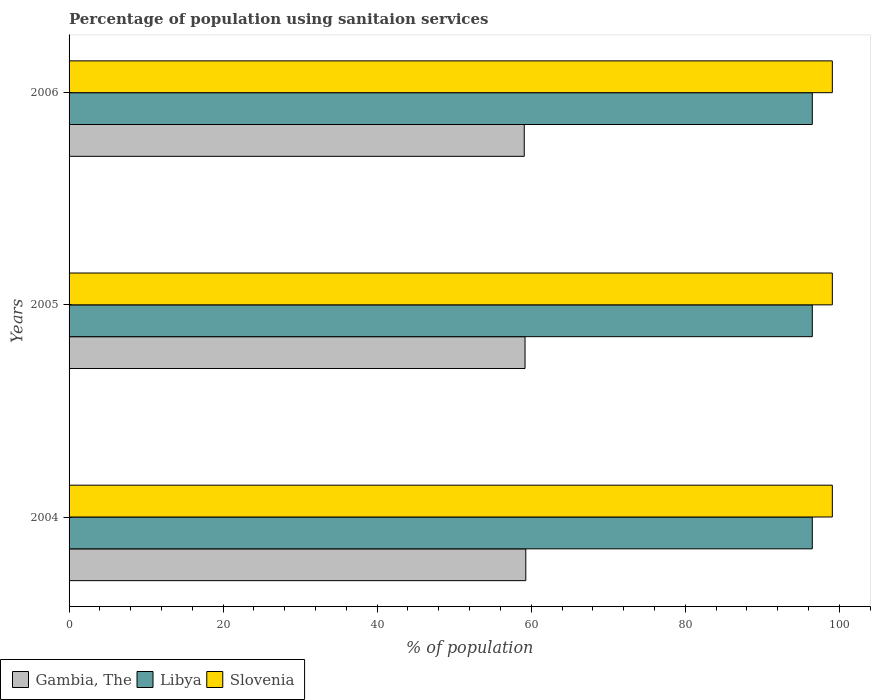How many different coloured bars are there?
Your answer should be very brief. 3. How many groups of bars are there?
Make the answer very short. 3. Are the number of bars per tick equal to the number of legend labels?
Your response must be concise. Yes. How many bars are there on the 2nd tick from the top?
Give a very brief answer. 3. How many bars are there on the 2nd tick from the bottom?
Give a very brief answer. 3. What is the label of the 3rd group of bars from the top?
Keep it short and to the point. 2004. What is the percentage of population using sanitaion services in Libya in 2005?
Make the answer very short. 96.5. Across all years, what is the maximum percentage of population using sanitaion services in Libya?
Provide a succinct answer. 96.5. Across all years, what is the minimum percentage of population using sanitaion services in Gambia, The?
Make the answer very short. 59.1. What is the total percentage of population using sanitaion services in Libya in the graph?
Your response must be concise. 289.5. What is the difference between the percentage of population using sanitaion services in Libya in 2005 and that in 2006?
Your answer should be compact. 0. What is the difference between the percentage of population using sanitaion services in Libya in 2004 and the percentage of population using sanitaion services in Slovenia in 2006?
Offer a terse response. -2.6. What is the average percentage of population using sanitaion services in Slovenia per year?
Make the answer very short. 99.1. In the year 2004, what is the difference between the percentage of population using sanitaion services in Gambia, The and percentage of population using sanitaion services in Libya?
Your answer should be very brief. -37.2. In how many years, is the percentage of population using sanitaion services in Slovenia greater than 88 %?
Offer a very short reply. 3. What is the ratio of the percentage of population using sanitaion services in Gambia, The in 2005 to that in 2006?
Provide a short and direct response. 1. Is the percentage of population using sanitaion services in Libya in 2005 less than that in 2006?
Your answer should be very brief. No. Is the difference between the percentage of population using sanitaion services in Gambia, The in 2004 and 2006 greater than the difference between the percentage of population using sanitaion services in Libya in 2004 and 2006?
Make the answer very short. Yes. What is the difference between the highest and the lowest percentage of population using sanitaion services in Gambia, The?
Offer a terse response. 0.2. What does the 1st bar from the top in 2004 represents?
Make the answer very short. Slovenia. What does the 1st bar from the bottom in 2004 represents?
Your response must be concise. Gambia, The. Are all the bars in the graph horizontal?
Provide a succinct answer. Yes. How many years are there in the graph?
Provide a short and direct response. 3. What is the difference between two consecutive major ticks on the X-axis?
Make the answer very short. 20. Does the graph contain grids?
Provide a succinct answer. No. How many legend labels are there?
Ensure brevity in your answer.  3. How are the legend labels stacked?
Offer a terse response. Horizontal. What is the title of the graph?
Provide a short and direct response. Percentage of population using sanitaion services. What is the label or title of the X-axis?
Make the answer very short. % of population. What is the label or title of the Y-axis?
Offer a very short reply. Years. What is the % of population in Gambia, The in 2004?
Your answer should be compact. 59.3. What is the % of population in Libya in 2004?
Your response must be concise. 96.5. What is the % of population of Slovenia in 2004?
Give a very brief answer. 99.1. What is the % of population of Gambia, The in 2005?
Your answer should be compact. 59.2. What is the % of population in Libya in 2005?
Provide a short and direct response. 96.5. What is the % of population in Slovenia in 2005?
Offer a terse response. 99.1. What is the % of population in Gambia, The in 2006?
Give a very brief answer. 59.1. What is the % of population in Libya in 2006?
Ensure brevity in your answer.  96.5. What is the % of population of Slovenia in 2006?
Ensure brevity in your answer.  99.1. Across all years, what is the maximum % of population in Gambia, The?
Keep it short and to the point. 59.3. Across all years, what is the maximum % of population of Libya?
Make the answer very short. 96.5. Across all years, what is the maximum % of population in Slovenia?
Offer a terse response. 99.1. Across all years, what is the minimum % of population in Gambia, The?
Keep it short and to the point. 59.1. Across all years, what is the minimum % of population of Libya?
Keep it short and to the point. 96.5. Across all years, what is the minimum % of population of Slovenia?
Offer a very short reply. 99.1. What is the total % of population in Gambia, The in the graph?
Ensure brevity in your answer.  177.6. What is the total % of population of Libya in the graph?
Your response must be concise. 289.5. What is the total % of population in Slovenia in the graph?
Your answer should be very brief. 297.3. What is the difference between the % of population of Libya in 2004 and that in 2005?
Provide a short and direct response. 0. What is the difference between the % of population of Slovenia in 2004 and that in 2005?
Your response must be concise. 0. What is the difference between the % of population in Gambia, The in 2004 and that in 2006?
Provide a succinct answer. 0.2. What is the difference between the % of population in Libya in 2004 and that in 2006?
Make the answer very short. 0. What is the difference between the % of population of Slovenia in 2004 and that in 2006?
Offer a very short reply. 0. What is the difference between the % of population in Libya in 2005 and that in 2006?
Provide a succinct answer. 0. What is the difference between the % of population of Slovenia in 2005 and that in 2006?
Your answer should be compact. 0. What is the difference between the % of population of Gambia, The in 2004 and the % of population of Libya in 2005?
Your answer should be compact. -37.2. What is the difference between the % of population in Gambia, The in 2004 and the % of population in Slovenia in 2005?
Give a very brief answer. -39.8. What is the difference between the % of population in Gambia, The in 2004 and the % of population in Libya in 2006?
Provide a succinct answer. -37.2. What is the difference between the % of population of Gambia, The in 2004 and the % of population of Slovenia in 2006?
Your answer should be compact. -39.8. What is the difference between the % of population in Gambia, The in 2005 and the % of population in Libya in 2006?
Offer a very short reply. -37.3. What is the difference between the % of population in Gambia, The in 2005 and the % of population in Slovenia in 2006?
Your answer should be compact. -39.9. What is the difference between the % of population in Libya in 2005 and the % of population in Slovenia in 2006?
Your response must be concise. -2.6. What is the average % of population in Gambia, The per year?
Give a very brief answer. 59.2. What is the average % of population in Libya per year?
Make the answer very short. 96.5. What is the average % of population in Slovenia per year?
Keep it short and to the point. 99.1. In the year 2004, what is the difference between the % of population of Gambia, The and % of population of Libya?
Offer a terse response. -37.2. In the year 2004, what is the difference between the % of population in Gambia, The and % of population in Slovenia?
Your response must be concise. -39.8. In the year 2005, what is the difference between the % of population of Gambia, The and % of population of Libya?
Provide a short and direct response. -37.3. In the year 2005, what is the difference between the % of population of Gambia, The and % of population of Slovenia?
Provide a short and direct response. -39.9. In the year 2006, what is the difference between the % of population in Gambia, The and % of population in Libya?
Give a very brief answer. -37.4. In the year 2006, what is the difference between the % of population of Libya and % of population of Slovenia?
Your answer should be compact. -2.6. What is the ratio of the % of population in Gambia, The in 2004 to that in 2005?
Your answer should be compact. 1. What is the ratio of the % of population in Libya in 2004 to that in 2005?
Keep it short and to the point. 1. What is the ratio of the % of population in Libya in 2004 to that in 2006?
Offer a very short reply. 1. What is the ratio of the % of population of Slovenia in 2004 to that in 2006?
Ensure brevity in your answer.  1. What is the ratio of the % of population in Slovenia in 2005 to that in 2006?
Your response must be concise. 1. What is the difference between the highest and the second highest % of population in Slovenia?
Offer a terse response. 0. What is the difference between the highest and the lowest % of population in Gambia, The?
Offer a very short reply. 0.2. What is the difference between the highest and the lowest % of population of Libya?
Ensure brevity in your answer.  0. 